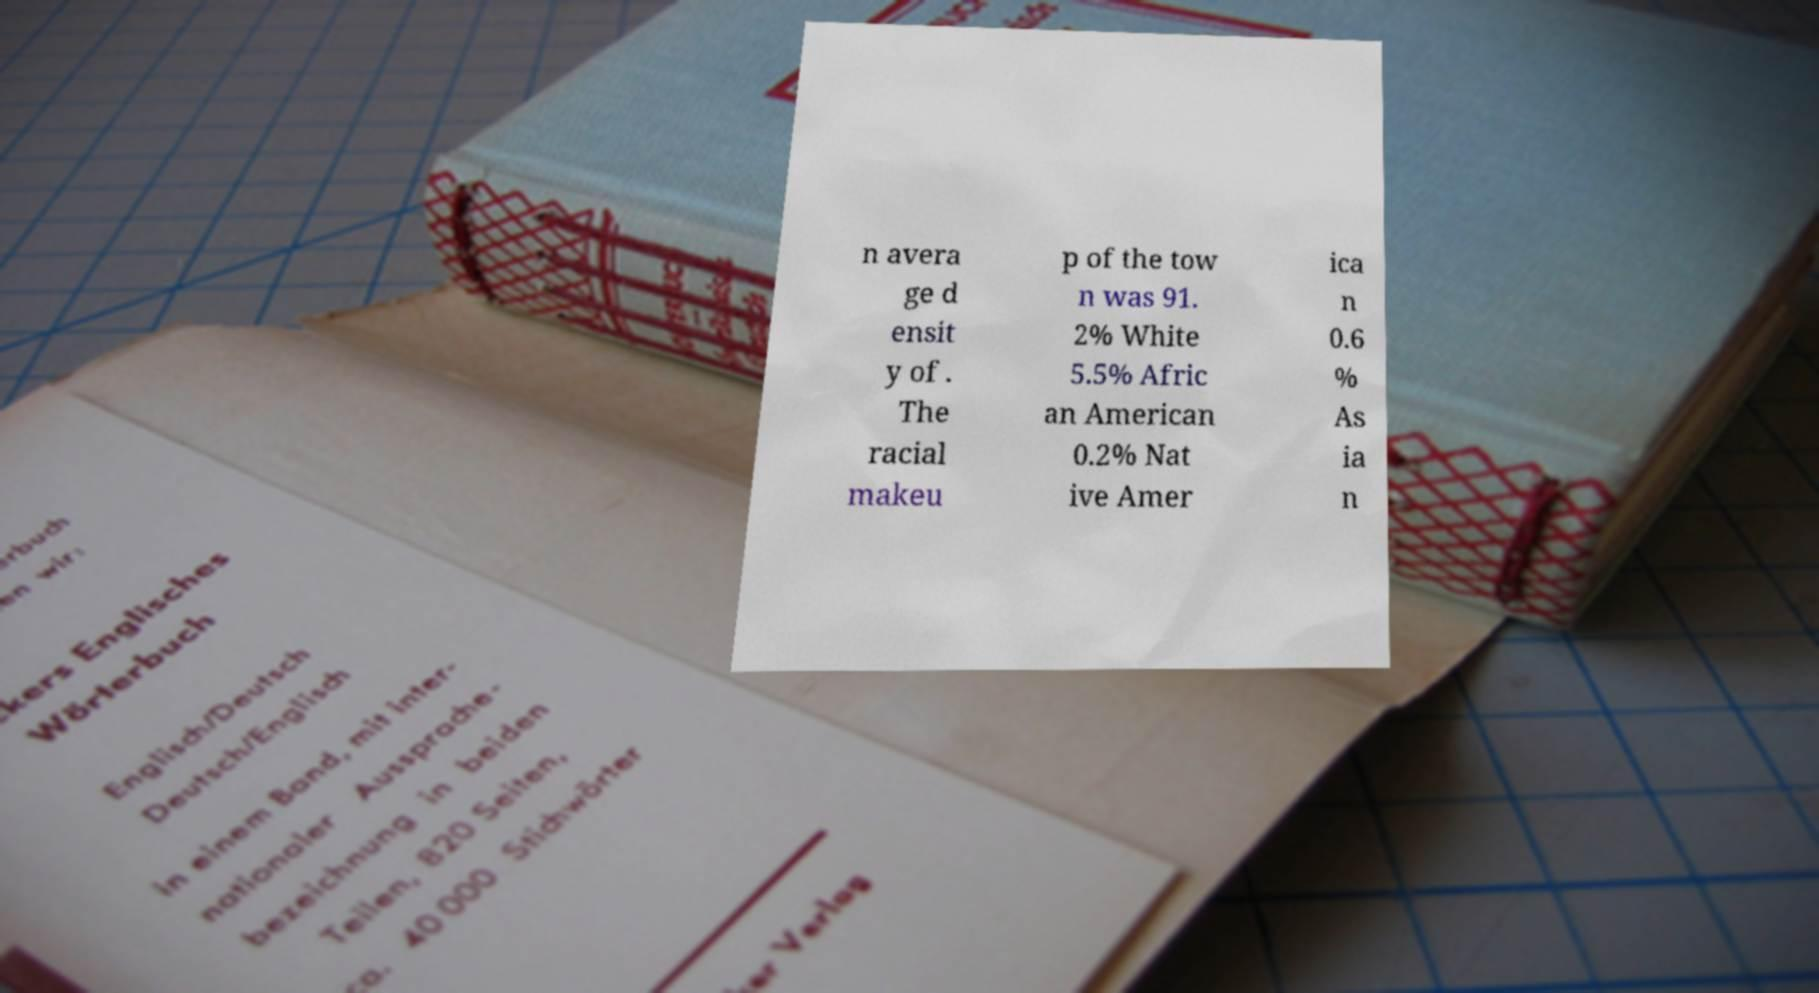What messages or text are displayed in this image? I need them in a readable, typed format. n avera ge d ensit y of . The racial makeu p of the tow n was 91. 2% White 5.5% Afric an American 0.2% Nat ive Amer ica n 0.6 % As ia n 